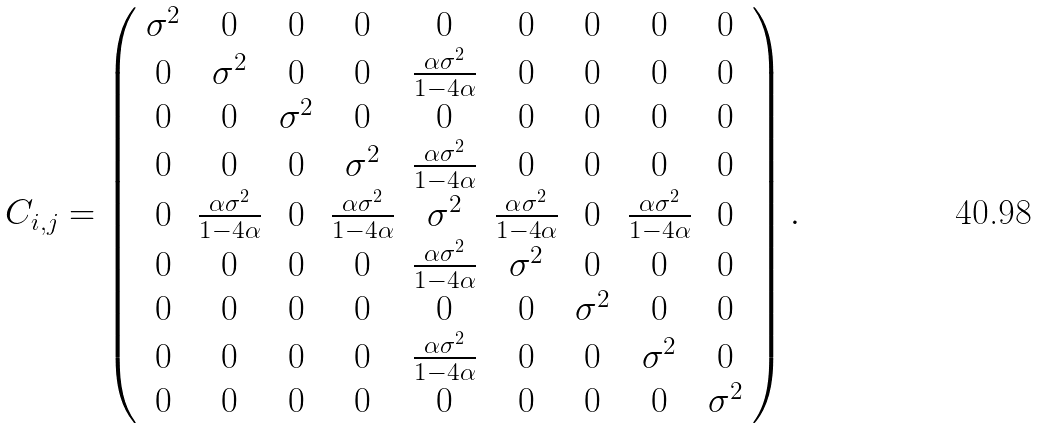Convert formula to latex. <formula><loc_0><loc_0><loc_500><loc_500>C _ { i , j } = \left ( \begin{array} { c c c c c c c c c } \sigma ^ { 2 } & 0 & 0 & 0 & 0 & 0 & 0 & 0 & 0 \\ 0 & \sigma ^ { 2 } & 0 & 0 & \frac { \alpha \sigma ^ { 2 } } { 1 - 4 \alpha } & 0 & 0 & 0 & 0 \\ 0 & 0 & \sigma ^ { 2 } & 0 & 0 & 0 & 0 & 0 & 0 \\ 0 & 0 & 0 & \sigma ^ { 2 } & \frac { \alpha \sigma ^ { 2 } } { 1 - 4 \alpha } & 0 & 0 & 0 & 0 \\ 0 & \frac { \alpha \sigma ^ { 2 } } { 1 - 4 \alpha } & 0 & \frac { \alpha \sigma ^ { 2 } } { 1 - 4 \alpha } & \sigma ^ { 2 } & \frac { \alpha \sigma ^ { 2 } } { 1 - 4 \alpha } & 0 & \frac { \alpha \sigma ^ { 2 } } { 1 - 4 \alpha } & 0 \\ 0 & 0 & 0 & 0 & \frac { \alpha \sigma ^ { 2 } } { 1 - 4 \alpha } & \sigma ^ { 2 } & 0 & 0 & 0 \\ 0 & 0 & 0 & 0 & 0 & 0 & \sigma ^ { 2 } & 0 & 0 \\ 0 & 0 & 0 & 0 & \frac { \alpha \sigma ^ { 2 } } { 1 - 4 \alpha } & 0 & 0 & \sigma ^ { 2 } & 0 \\ 0 & 0 & 0 & 0 & 0 & 0 & 0 & 0 & \sigma ^ { 2 } \end{array} \right ) .</formula> 